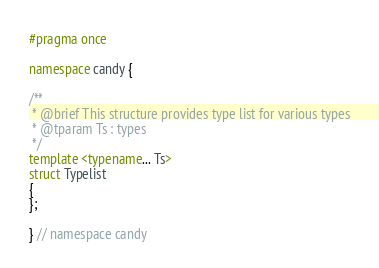<code> <loc_0><loc_0><loc_500><loc_500><_C++_>
#pragma once

namespace candy {

/**
 * @brief This structure provides type list for various types
 * @tparam Ts : types
 */
template <typename... Ts>
struct Typelist
{
};

} // namespace candy
</code> 